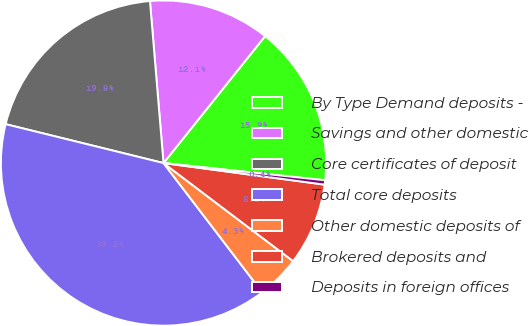<chart> <loc_0><loc_0><loc_500><loc_500><pie_chart><fcel>By Type Demand deposits -<fcel>Savings and other domestic<fcel>Core certificates of deposit<fcel>Total core deposits<fcel>Other domestic deposits of<fcel>Brokered deposits and<fcel>Deposits in foreign offices<nl><fcel>15.95%<fcel>12.07%<fcel>19.83%<fcel>39.23%<fcel>4.31%<fcel>8.19%<fcel>0.43%<nl></chart> 